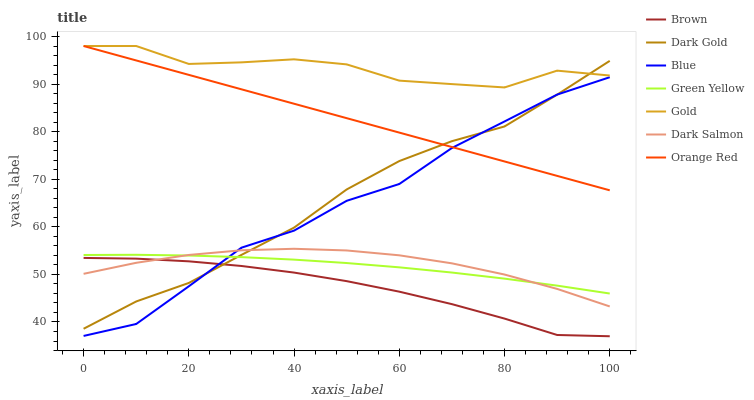Does Brown have the minimum area under the curve?
Answer yes or no. Yes. Does Gold have the maximum area under the curve?
Answer yes or no. Yes. Does Gold have the minimum area under the curve?
Answer yes or no. No. Does Brown have the maximum area under the curve?
Answer yes or no. No. Is Orange Red the smoothest?
Answer yes or no. Yes. Is Gold the roughest?
Answer yes or no. Yes. Is Brown the smoothest?
Answer yes or no. No. Is Brown the roughest?
Answer yes or no. No. Does Brown have the lowest value?
Answer yes or no. Yes. Does Gold have the lowest value?
Answer yes or no. No. Does Orange Red have the highest value?
Answer yes or no. Yes. Does Brown have the highest value?
Answer yes or no. No. Is Green Yellow less than Gold?
Answer yes or no. Yes. Is Orange Red greater than Brown?
Answer yes or no. Yes. Does Green Yellow intersect Blue?
Answer yes or no. Yes. Is Green Yellow less than Blue?
Answer yes or no. No. Is Green Yellow greater than Blue?
Answer yes or no. No. Does Green Yellow intersect Gold?
Answer yes or no. No. 